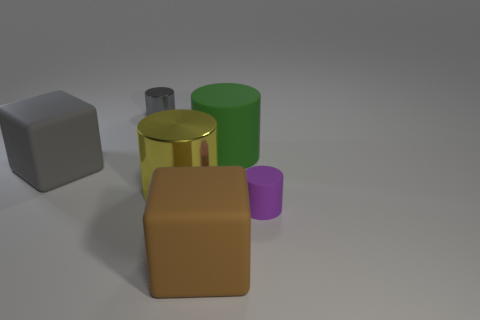What is the material of the block right of the small metallic object?
Ensure brevity in your answer.  Rubber. What size is the green cylinder?
Provide a short and direct response. Large. Is the material of the small cylinder to the right of the small gray thing the same as the tiny gray thing?
Your response must be concise. No. What number of small cylinders are there?
Keep it short and to the point. 2. What number of things are purple rubber cylinders or green cylinders?
Provide a short and direct response. 2. There is a small object in front of the matte cube behind the purple matte object; how many large yellow cylinders are right of it?
Ensure brevity in your answer.  0. Are there any other things of the same color as the small matte object?
Offer a very short reply. No. Do the matte cylinder that is behind the purple rubber cylinder and the big block behind the big brown matte thing have the same color?
Keep it short and to the point. No. Are there more objects in front of the big yellow shiny object than large cylinders left of the large gray matte cube?
Provide a succinct answer. Yes. What is the material of the gray cube?
Make the answer very short. Rubber. 